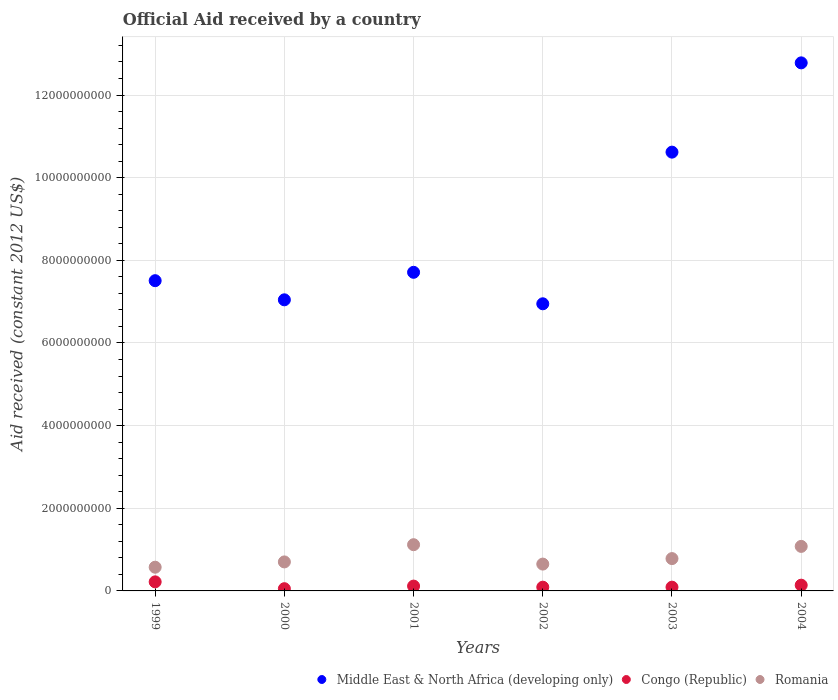Is the number of dotlines equal to the number of legend labels?
Offer a very short reply. Yes. What is the net official aid received in Middle East & North Africa (developing only) in 2003?
Keep it short and to the point. 1.06e+1. Across all years, what is the maximum net official aid received in Congo (Republic)?
Provide a succinct answer. 2.19e+08. Across all years, what is the minimum net official aid received in Romania?
Give a very brief answer. 5.74e+08. What is the total net official aid received in Congo (Republic) in the graph?
Provide a succinct answer. 7.10e+08. What is the difference between the net official aid received in Congo (Republic) in 2000 and that in 2003?
Offer a very short reply. -3.72e+07. What is the difference between the net official aid received in Congo (Republic) in 1999 and the net official aid received in Middle East & North Africa (developing only) in 2000?
Ensure brevity in your answer.  -6.83e+09. What is the average net official aid received in Congo (Republic) per year?
Give a very brief answer. 1.18e+08. In the year 2002, what is the difference between the net official aid received in Congo (Republic) and net official aid received in Romania?
Your answer should be compact. -5.59e+08. What is the ratio of the net official aid received in Romania in 2001 to that in 2004?
Offer a very short reply. 1.04. What is the difference between the highest and the second highest net official aid received in Romania?
Offer a very short reply. 4.10e+07. What is the difference between the highest and the lowest net official aid received in Congo (Republic)?
Ensure brevity in your answer.  1.65e+08. Is the sum of the net official aid received in Romania in 2000 and 2002 greater than the maximum net official aid received in Middle East & North Africa (developing only) across all years?
Give a very brief answer. No. Is the net official aid received in Romania strictly greater than the net official aid received in Congo (Republic) over the years?
Ensure brevity in your answer.  Yes. Is the net official aid received in Congo (Republic) strictly less than the net official aid received in Romania over the years?
Give a very brief answer. Yes. How many years are there in the graph?
Provide a short and direct response. 6. Does the graph contain any zero values?
Your answer should be compact. No. Where does the legend appear in the graph?
Keep it short and to the point. Bottom right. How many legend labels are there?
Provide a succinct answer. 3. What is the title of the graph?
Your answer should be compact. Official Aid received by a country. Does "Namibia" appear as one of the legend labels in the graph?
Provide a short and direct response. No. What is the label or title of the X-axis?
Offer a very short reply. Years. What is the label or title of the Y-axis?
Offer a very short reply. Aid received (constant 2012 US$). What is the Aid received (constant 2012 US$) of Middle East & North Africa (developing only) in 1999?
Your response must be concise. 7.51e+09. What is the Aid received (constant 2012 US$) in Congo (Republic) in 1999?
Your answer should be compact. 2.19e+08. What is the Aid received (constant 2012 US$) of Romania in 1999?
Provide a short and direct response. 5.74e+08. What is the Aid received (constant 2012 US$) of Middle East & North Africa (developing only) in 2000?
Ensure brevity in your answer.  7.04e+09. What is the Aid received (constant 2012 US$) in Congo (Republic) in 2000?
Your answer should be very brief. 5.38e+07. What is the Aid received (constant 2012 US$) of Romania in 2000?
Your answer should be very brief. 7.02e+08. What is the Aid received (constant 2012 US$) of Middle East & North Africa (developing only) in 2001?
Your answer should be very brief. 7.71e+09. What is the Aid received (constant 2012 US$) in Congo (Republic) in 2001?
Your response must be concise. 1.17e+08. What is the Aid received (constant 2012 US$) in Romania in 2001?
Provide a succinct answer. 1.12e+09. What is the Aid received (constant 2012 US$) of Middle East & North Africa (developing only) in 2002?
Your answer should be very brief. 6.95e+09. What is the Aid received (constant 2012 US$) of Congo (Republic) in 2002?
Your answer should be compact. 9.06e+07. What is the Aid received (constant 2012 US$) in Romania in 2002?
Make the answer very short. 6.49e+08. What is the Aid received (constant 2012 US$) in Middle East & North Africa (developing only) in 2003?
Give a very brief answer. 1.06e+1. What is the Aid received (constant 2012 US$) in Congo (Republic) in 2003?
Ensure brevity in your answer.  9.11e+07. What is the Aid received (constant 2012 US$) of Romania in 2003?
Your answer should be compact. 7.82e+08. What is the Aid received (constant 2012 US$) of Middle East & North Africa (developing only) in 2004?
Your answer should be very brief. 1.28e+1. What is the Aid received (constant 2012 US$) of Congo (Republic) in 2004?
Provide a succinct answer. 1.39e+08. What is the Aid received (constant 2012 US$) in Romania in 2004?
Offer a very short reply. 1.08e+09. Across all years, what is the maximum Aid received (constant 2012 US$) in Middle East & North Africa (developing only)?
Provide a short and direct response. 1.28e+1. Across all years, what is the maximum Aid received (constant 2012 US$) of Congo (Republic)?
Offer a very short reply. 2.19e+08. Across all years, what is the maximum Aid received (constant 2012 US$) of Romania?
Your answer should be very brief. 1.12e+09. Across all years, what is the minimum Aid received (constant 2012 US$) of Middle East & North Africa (developing only)?
Your answer should be very brief. 6.95e+09. Across all years, what is the minimum Aid received (constant 2012 US$) of Congo (Republic)?
Give a very brief answer. 5.38e+07. Across all years, what is the minimum Aid received (constant 2012 US$) in Romania?
Make the answer very short. 5.74e+08. What is the total Aid received (constant 2012 US$) in Middle East & North Africa (developing only) in the graph?
Your answer should be very brief. 5.26e+1. What is the total Aid received (constant 2012 US$) of Congo (Republic) in the graph?
Offer a terse response. 7.10e+08. What is the total Aid received (constant 2012 US$) of Romania in the graph?
Offer a very short reply. 4.90e+09. What is the difference between the Aid received (constant 2012 US$) of Middle East & North Africa (developing only) in 1999 and that in 2000?
Ensure brevity in your answer.  4.63e+08. What is the difference between the Aid received (constant 2012 US$) in Congo (Republic) in 1999 and that in 2000?
Your response must be concise. 1.65e+08. What is the difference between the Aid received (constant 2012 US$) in Romania in 1999 and that in 2000?
Ensure brevity in your answer.  -1.28e+08. What is the difference between the Aid received (constant 2012 US$) of Middle East & North Africa (developing only) in 1999 and that in 2001?
Provide a succinct answer. -2.03e+08. What is the difference between the Aid received (constant 2012 US$) of Congo (Republic) in 1999 and that in 2001?
Your answer should be very brief. 1.02e+08. What is the difference between the Aid received (constant 2012 US$) of Romania in 1999 and that in 2001?
Make the answer very short. -5.45e+08. What is the difference between the Aid received (constant 2012 US$) of Middle East & North Africa (developing only) in 1999 and that in 2002?
Ensure brevity in your answer.  5.59e+08. What is the difference between the Aid received (constant 2012 US$) of Congo (Republic) in 1999 and that in 2002?
Give a very brief answer. 1.29e+08. What is the difference between the Aid received (constant 2012 US$) of Romania in 1999 and that in 2002?
Provide a succinct answer. -7.56e+07. What is the difference between the Aid received (constant 2012 US$) of Middle East & North Africa (developing only) in 1999 and that in 2003?
Your response must be concise. -3.11e+09. What is the difference between the Aid received (constant 2012 US$) in Congo (Republic) in 1999 and that in 2003?
Your answer should be compact. 1.28e+08. What is the difference between the Aid received (constant 2012 US$) of Romania in 1999 and that in 2003?
Give a very brief answer. -2.09e+08. What is the difference between the Aid received (constant 2012 US$) in Middle East & North Africa (developing only) in 1999 and that in 2004?
Make the answer very short. -5.27e+09. What is the difference between the Aid received (constant 2012 US$) of Congo (Republic) in 1999 and that in 2004?
Offer a very short reply. 8.02e+07. What is the difference between the Aid received (constant 2012 US$) in Romania in 1999 and that in 2004?
Ensure brevity in your answer.  -5.04e+08. What is the difference between the Aid received (constant 2012 US$) in Middle East & North Africa (developing only) in 2000 and that in 2001?
Ensure brevity in your answer.  -6.66e+08. What is the difference between the Aid received (constant 2012 US$) of Congo (Republic) in 2000 and that in 2001?
Your answer should be compact. -6.31e+07. What is the difference between the Aid received (constant 2012 US$) of Romania in 2000 and that in 2001?
Your answer should be very brief. -4.17e+08. What is the difference between the Aid received (constant 2012 US$) of Middle East & North Africa (developing only) in 2000 and that in 2002?
Give a very brief answer. 9.62e+07. What is the difference between the Aid received (constant 2012 US$) in Congo (Republic) in 2000 and that in 2002?
Give a very brief answer. -3.68e+07. What is the difference between the Aid received (constant 2012 US$) of Romania in 2000 and that in 2002?
Your response must be concise. 5.26e+07. What is the difference between the Aid received (constant 2012 US$) of Middle East & North Africa (developing only) in 2000 and that in 2003?
Provide a succinct answer. -3.57e+09. What is the difference between the Aid received (constant 2012 US$) in Congo (Republic) in 2000 and that in 2003?
Keep it short and to the point. -3.72e+07. What is the difference between the Aid received (constant 2012 US$) of Romania in 2000 and that in 2003?
Provide a succinct answer. -8.04e+07. What is the difference between the Aid received (constant 2012 US$) of Middle East & North Africa (developing only) in 2000 and that in 2004?
Offer a terse response. -5.73e+09. What is the difference between the Aid received (constant 2012 US$) in Congo (Republic) in 2000 and that in 2004?
Your answer should be compact. -8.52e+07. What is the difference between the Aid received (constant 2012 US$) in Romania in 2000 and that in 2004?
Ensure brevity in your answer.  -3.76e+08. What is the difference between the Aid received (constant 2012 US$) of Middle East & North Africa (developing only) in 2001 and that in 2002?
Your answer should be compact. 7.62e+08. What is the difference between the Aid received (constant 2012 US$) of Congo (Republic) in 2001 and that in 2002?
Provide a short and direct response. 2.63e+07. What is the difference between the Aid received (constant 2012 US$) in Romania in 2001 and that in 2002?
Ensure brevity in your answer.  4.69e+08. What is the difference between the Aid received (constant 2012 US$) of Middle East & North Africa (developing only) in 2001 and that in 2003?
Your answer should be very brief. -2.91e+09. What is the difference between the Aid received (constant 2012 US$) of Congo (Republic) in 2001 and that in 2003?
Keep it short and to the point. 2.58e+07. What is the difference between the Aid received (constant 2012 US$) in Romania in 2001 and that in 2003?
Make the answer very short. 3.36e+08. What is the difference between the Aid received (constant 2012 US$) in Middle East & North Africa (developing only) in 2001 and that in 2004?
Your response must be concise. -5.07e+09. What is the difference between the Aid received (constant 2012 US$) of Congo (Republic) in 2001 and that in 2004?
Keep it short and to the point. -2.21e+07. What is the difference between the Aid received (constant 2012 US$) in Romania in 2001 and that in 2004?
Offer a very short reply. 4.10e+07. What is the difference between the Aid received (constant 2012 US$) in Middle East & North Africa (developing only) in 2002 and that in 2003?
Keep it short and to the point. -3.67e+09. What is the difference between the Aid received (constant 2012 US$) of Congo (Republic) in 2002 and that in 2003?
Your answer should be compact. -5.00e+05. What is the difference between the Aid received (constant 2012 US$) of Romania in 2002 and that in 2003?
Keep it short and to the point. -1.33e+08. What is the difference between the Aid received (constant 2012 US$) in Middle East & North Africa (developing only) in 2002 and that in 2004?
Give a very brief answer. -5.83e+09. What is the difference between the Aid received (constant 2012 US$) in Congo (Republic) in 2002 and that in 2004?
Give a very brief answer. -4.84e+07. What is the difference between the Aid received (constant 2012 US$) in Romania in 2002 and that in 2004?
Give a very brief answer. -4.28e+08. What is the difference between the Aid received (constant 2012 US$) of Middle East & North Africa (developing only) in 2003 and that in 2004?
Keep it short and to the point. -2.16e+09. What is the difference between the Aid received (constant 2012 US$) in Congo (Republic) in 2003 and that in 2004?
Give a very brief answer. -4.79e+07. What is the difference between the Aid received (constant 2012 US$) in Romania in 2003 and that in 2004?
Your response must be concise. -2.95e+08. What is the difference between the Aid received (constant 2012 US$) in Middle East & North Africa (developing only) in 1999 and the Aid received (constant 2012 US$) in Congo (Republic) in 2000?
Offer a very short reply. 7.45e+09. What is the difference between the Aid received (constant 2012 US$) of Middle East & North Africa (developing only) in 1999 and the Aid received (constant 2012 US$) of Romania in 2000?
Give a very brief answer. 6.81e+09. What is the difference between the Aid received (constant 2012 US$) in Congo (Republic) in 1999 and the Aid received (constant 2012 US$) in Romania in 2000?
Offer a very short reply. -4.83e+08. What is the difference between the Aid received (constant 2012 US$) in Middle East & North Africa (developing only) in 1999 and the Aid received (constant 2012 US$) in Congo (Republic) in 2001?
Keep it short and to the point. 7.39e+09. What is the difference between the Aid received (constant 2012 US$) in Middle East & North Africa (developing only) in 1999 and the Aid received (constant 2012 US$) in Romania in 2001?
Give a very brief answer. 6.39e+09. What is the difference between the Aid received (constant 2012 US$) of Congo (Republic) in 1999 and the Aid received (constant 2012 US$) of Romania in 2001?
Keep it short and to the point. -8.99e+08. What is the difference between the Aid received (constant 2012 US$) of Middle East & North Africa (developing only) in 1999 and the Aid received (constant 2012 US$) of Congo (Republic) in 2002?
Offer a very short reply. 7.42e+09. What is the difference between the Aid received (constant 2012 US$) in Middle East & North Africa (developing only) in 1999 and the Aid received (constant 2012 US$) in Romania in 2002?
Your response must be concise. 6.86e+09. What is the difference between the Aid received (constant 2012 US$) of Congo (Republic) in 1999 and the Aid received (constant 2012 US$) of Romania in 2002?
Your answer should be very brief. -4.30e+08. What is the difference between the Aid received (constant 2012 US$) of Middle East & North Africa (developing only) in 1999 and the Aid received (constant 2012 US$) of Congo (Republic) in 2003?
Give a very brief answer. 7.42e+09. What is the difference between the Aid received (constant 2012 US$) in Middle East & North Africa (developing only) in 1999 and the Aid received (constant 2012 US$) in Romania in 2003?
Provide a short and direct response. 6.72e+09. What is the difference between the Aid received (constant 2012 US$) of Congo (Republic) in 1999 and the Aid received (constant 2012 US$) of Romania in 2003?
Give a very brief answer. -5.63e+08. What is the difference between the Aid received (constant 2012 US$) of Middle East & North Africa (developing only) in 1999 and the Aid received (constant 2012 US$) of Congo (Republic) in 2004?
Your answer should be very brief. 7.37e+09. What is the difference between the Aid received (constant 2012 US$) in Middle East & North Africa (developing only) in 1999 and the Aid received (constant 2012 US$) in Romania in 2004?
Your response must be concise. 6.43e+09. What is the difference between the Aid received (constant 2012 US$) in Congo (Republic) in 1999 and the Aid received (constant 2012 US$) in Romania in 2004?
Offer a very short reply. -8.58e+08. What is the difference between the Aid received (constant 2012 US$) in Middle East & North Africa (developing only) in 2000 and the Aid received (constant 2012 US$) in Congo (Republic) in 2001?
Your response must be concise. 6.93e+09. What is the difference between the Aid received (constant 2012 US$) of Middle East & North Africa (developing only) in 2000 and the Aid received (constant 2012 US$) of Romania in 2001?
Offer a terse response. 5.93e+09. What is the difference between the Aid received (constant 2012 US$) of Congo (Republic) in 2000 and the Aid received (constant 2012 US$) of Romania in 2001?
Offer a terse response. -1.06e+09. What is the difference between the Aid received (constant 2012 US$) of Middle East & North Africa (developing only) in 2000 and the Aid received (constant 2012 US$) of Congo (Republic) in 2002?
Provide a succinct answer. 6.95e+09. What is the difference between the Aid received (constant 2012 US$) of Middle East & North Africa (developing only) in 2000 and the Aid received (constant 2012 US$) of Romania in 2002?
Provide a succinct answer. 6.40e+09. What is the difference between the Aid received (constant 2012 US$) of Congo (Republic) in 2000 and the Aid received (constant 2012 US$) of Romania in 2002?
Keep it short and to the point. -5.95e+08. What is the difference between the Aid received (constant 2012 US$) in Middle East & North Africa (developing only) in 2000 and the Aid received (constant 2012 US$) in Congo (Republic) in 2003?
Ensure brevity in your answer.  6.95e+09. What is the difference between the Aid received (constant 2012 US$) in Middle East & North Africa (developing only) in 2000 and the Aid received (constant 2012 US$) in Romania in 2003?
Ensure brevity in your answer.  6.26e+09. What is the difference between the Aid received (constant 2012 US$) of Congo (Republic) in 2000 and the Aid received (constant 2012 US$) of Romania in 2003?
Ensure brevity in your answer.  -7.28e+08. What is the difference between the Aid received (constant 2012 US$) of Middle East & North Africa (developing only) in 2000 and the Aid received (constant 2012 US$) of Congo (Republic) in 2004?
Your answer should be compact. 6.91e+09. What is the difference between the Aid received (constant 2012 US$) in Middle East & North Africa (developing only) in 2000 and the Aid received (constant 2012 US$) in Romania in 2004?
Provide a succinct answer. 5.97e+09. What is the difference between the Aid received (constant 2012 US$) of Congo (Republic) in 2000 and the Aid received (constant 2012 US$) of Romania in 2004?
Ensure brevity in your answer.  -1.02e+09. What is the difference between the Aid received (constant 2012 US$) of Middle East & North Africa (developing only) in 2001 and the Aid received (constant 2012 US$) of Congo (Republic) in 2002?
Make the answer very short. 7.62e+09. What is the difference between the Aid received (constant 2012 US$) of Middle East & North Africa (developing only) in 2001 and the Aid received (constant 2012 US$) of Romania in 2002?
Offer a terse response. 7.06e+09. What is the difference between the Aid received (constant 2012 US$) in Congo (Republic) in 2001 and the Aid received (constant 2012 US$) in Romania in 2002?
Provide a succinct answer. -5.32e+08. What is the difference between the Aid received (constant 2012 US$) in Middle East & North Africa (developing only) in 2001 and the Aid received (constant 2012 US$) in Congo (Republic) in 2003?
Offer a terse response. 7.62e+09. What is the difference between the Aid received (constant 2012 US$) of Middle East & North Africa (developing only) in 2001 and the Aid received (constant 2012 US$) of Romania in 2003?
Ensure brevity in your answer.  6.93e+09. What is the difference between the Aid received (constant 2012 US$) of Congo (Republic) in 2001 and the Aid received (constant 2012 US$) of Romania in 2003?
Offer a very short reply. -6.65e+08. What is the difference between the Aid received (constant 2012 US$) in Middle East & North Africa (developing only) in 2001 and the Aid received (constant 2012 US$) in Congo (Republic) in 2004?
Provide a short and direct response. 7.57e+09. What is the difference between the Aid received (constant 2012 US$) of Middle East & North Africa (developing only) in 2001 and the Aid received (constant 2012 US$) of Romania in 2004?
Make the answer very short. 6.63e+09. What is the difference between the Aid received (constant 2012 US$) of Congo (Republic) in 2001 and the Aid received (constant 2012 US$) of Romania in 2004?
Ensure brevity in your answer.  -9.61e+08. What is the difference between the Aid received (constant 2012 US$) in Middle East & North Africa (developing only) in 2002 and the Aid received (constant 2012 US$) in Congo (Republic) in 2003?
Offer a very short reply. 6.86e+09. What is the difference between the Aid received (constant 2012 US$) of Middle East & North Africa (developing only) in 2002 and the Aid received (constant 2012 US$) of Romania in 2003?
Keep it short and to the point. 6.17e+09. What is the difference between the Aid received (constant 2012 US$) in Congo (Republic) in 2002 and the Aid received (constant 2012 US$) in Romania in 2003?
Make the answer very short. -6.92e+08. What is the difference between the Aid received (constant 2012 US$) of Middle East & North Africa (developing only) in 2002 and the Aid received (constant 2012 US$) of Congo (Republic) in 2004?
Offer a very short reply. 6.81e+09. What is the difference between the Aid received (constant 2012 US$) in Middle East & North Africa (developing only) in 2002 and the Aid received (constant 2012 US$) in Romania in 2004?
Make the answer very short. 5.87e+09. What is the difference between the Aid received (constant 2012 US$) of Congo (Republic) in 2002 and the Aid received (constant 2012 US$) of Romania in 2004?
Offer a terse response. -9.87e+08. What is the difference between the Aid received (constant 2012 US$) in Middle East & North Africa (developing only) in 2003 and the Aid received (constant 2012 US$) in Congo (Republic) in 2004?
Offer a terse response. 1.05e+1. What is the difference between the Aid received (constant 2012 US$) in Middle East & North Africa (developing only) in 2003 and the Aid received (constant 2012 US$) in Romania in 2004?
Provide a short and direct response. 9.54e+09. What is the difference between the Aid received (constant 2012 US$) in Congo (Republic) in 2003 and the Aid received (constant 2012 US$) in Romania in 2004?
Keep it short and to the point. -9.86e+08. What is the average Aid received (constant 2012 US$) in Middle East & North Africa (developing only) per year?
Your answer should be compact. 8.77e+09. What is the average Aid received (constant 2012 US$) in Congo (Republic) per year?
Your answer should be very brief. 1.18e+08. What is the average Aid received (constant 2012 US$) in Romania per year?
Offer a terse response. 8.17e+08. In the year 1999, what is the difference between the Aid received (constant 2012 US$) of Middle East & North Africa (developing only) and Aid received (constant 2012 US$) of Congo (Republic)?
Provide a short and direct response. 7.29e+09. In the year 1999, what is the difference between the Aid received (constant 2012 US$) in Middle East & North Africa (developing only) and Aid received (constant 2012 US$) in Romania?
Your answer should be very brief. 6.93e+09. In the year 1999, what is the difference between the Aid received (constant 2012 US$) in Congo (Republic) and Aid received (constant 2012 US$) in Romania?
Provide a succinct answer. -3.54e+08. In the year 2000, what is the difference between the Aid received (constant 2012 US$) of Middle East & North Africa (developing only) and Aid received (constant 2012 US$) of Congo (Republic)?
Offer a terse response. 6.99e+09. In the year 2000, what is the difference between the Aid received (constant 2012 US$) of Middle East & North Africa (developing only) and Aid received (constant 2012 US$) of Romania?
Keep it short and to the point. 6.34e+09. In the year 2000, what is the difference between the Aid received (constant 2012 US$) in Congo (Republic) and Aid received (constant 2012 US$) in Romania?
Your answer should be very brief. -6.48e+08. In the year 2001, what is the difference between the Aid received (constant 2012 US$) in Middle East & North Africa (developing only) and Aid received (constant 2012 US$) in Congo (Republic)?
Provide a succinct answer. 7.59e+09. In the year 2001, what is the difference between the Aid received (constant 2012 US$) in Middle East & North Africa (developing only) and Aid received (constant 2012 US$) in Romania?
Provide a succinct answer. 6.59e+09. In the year 2001, what is the difference between the Aid received (constant 2012 US$) of Congo (Republic) and Aid received (constant 2012 US$) of Romania?
Your answer should be very brief. -1.00e+09. In the year 2002, what is the difference between the Aid received (constant 2012 US$) in Middle East & North Africa (developing only) and Aid received (constant 2012 US$) in Congo (Republic)?
Your answer should be compact. 6.86e+09. In the year 2002, what is the difference between the Aid received (constant 2012 US$) of Middle East & North Africa (developing only) and Aid received (constant 2012 US$) of Romania?
Offer a terse response. 6.30e+09. In the year 2002, what is the difference between the Aid received (constant 2012 US$) of Congo (Republic) and Aid received (constant 2012 US$) of Romania?
Your answer should be very brief. -5.59e+08. In the year 2003, what is the difference between the Aid received (constant 2012 US$) in Middle East & North Africa (developing only) and Aid received (constant 2012 US$) in Congo (Republic)?
Offer a very short reply. 1.05e+1. In the year 2003, what is the difference between the Aid received (constant 2012 US$) of Middle East & North Africa (developing only) and Aid received (constant 2012 US$) of Romania?
Provide a succinct answer. 9.84e+09. In the year 2003, what is the difference between the Aid received (constant 2012 US$) in Congo (Republic) and Aid received (constant 2012 US$) in Romania?
Provide a short and direct response. -6.91e+08. In the year 2004, what is the difference between the Aid received (constant 2012 US$) in Middle East & North Africa (developing only) and Aid received (constant 2012 US$) in Congo (Republic)?
Offer a terse response. 1.26e+1. In the year 2004, what is the difference between the Aid received (constant 2012 US$) in Middle East & North Africa (developing only) and Aid received (constant 2012 US$) in Romania?
Offer a very short reply. 1.17e+1. In the year 2004, what is the difference between the Aid received (constant 2012 US$) in Congo (Republic) and Aid received (constant 2012 US$) in Romania?
Your response must be concise. -9.38e+08. What is the ratio of the Aid received (constant 2012 US$) in Middle East & North Africa (developing only) in 1999 to that in 2000?
Provide a succinct answer. 1.07. What is the ratio of the Aid received (constant 2012 US$) in Congo (Republic) in 1999 to that in 2000?
Give a very brief answer. 4.07. What is the ratio of the Aid received (constant 2012 US$) of Romania in 1999 to that in 2000?
Offer a very short reply. 0.82. What is the ratio of the Aid received (constant 2012 US$) in Middle East & North Africa (developing only) in 1999 to that in 2001?
Offer a terse response. 0.97. What is the ratio of the Aid received (constant 2012 US$) of Congo (Republic) in 1999 to that in 2001?
Offer a very short reply. 1.88. What is the ratio of the Aid received (constant 2012 US$) of Romania in 1999 to that in 2001?
Your answer should be very brief. 0.51. What is the ratio of the Aid received (constant 2012 US$) of Middle East & North Africa (developing only) in 1999 to that in 2002?
Provide a short and direct response. 1.08. What is the ratio of the Aid received (constant 2012 US$) in Congo (Republic) in 1999 to that in 2002?
Ensure brevity in your answer.  2.42. What is the ratio of the Aid received (constant 2012 US$) of Romania in 1999 to that in 2002?
Your answer should be compact. 0.88. What is the ratio of the Aid received (constant 2012 US$) in Middle East & North Africa (developing only) in 1999 to that in 2003?
Keep it short and to the point. 0.71. What is the ratio of the Aid received (constant 2012 US$) of Congo (Republic) in 1999 to that in 2003?
Make the answer very short. 2.41. What is the ratio of the Aid received (constant 2012 US$) in Romania in 1999 to that in 2003?
Provide a succinct answer. 0.73. What is the ratio of the Aid received (constant 2012 US$) of Middle East & North Africa (developing only) in 1999 to that in 2004?
Offer a very short reply. 0.59. What is the ratio of the Aid received (constant 2012 US$) of Congo (Republic) in 1999 to that in 2004?
Your answer should be very brief. 1.58. What is the ratio of the Aid received (constant 2012 US$) of Romania in 1999 to that in 2004?
Keep it short and to the point. 0.53. What is the ratio of the Aid received (constant 2012 US$) of Middle East & North Africa (developing only) in 2000 to that in 2001?
Offer a very short reply. 0.91. What is the ratio of the Aid received (constant 2012 US$) in Congo (Republic) in 2000 to that in 2001?
Your answer should be compact. 0.46. What is the ratio of the Aid received (constant 2012 US$) of Romania in 2000 to that in 2001?
Your response must be concise. 0.63. What is the ratio of the Aid received (constant 2012 US$) in Middle East & North Africa (developing only) in 2000 to that in 2002?
Make the answer very short. 1.01. What is the ratio of the Aid received (constant 2012 US$) of Congo (Republic) in 2000 to that in 2002?
Your answer should be very brief. 0.59. What is the ratio of the Aid received (constant 2012 US$) in Romania in 2000 to that in 2002?
Your answer should be very brief. 1.08. What is the ratio of the Aid received (constant 2012 US$) in Middle East & North Africa (developing only) in 2000 to that in 2003?
Offer a terse response. 0.66. What is the ratio of the Aid received (constant 2012 US$) of Congo (Republic) in 2000 to that in 2003?
Ensure brevity in your answer.  0.59. What is the ratio of the Aid received (constant 2012 US$) of Romania in 2000 to that in 2003?
Keep it short and to the point. 0.9. What is the ratio of the Aid received (constant 2012 US$) of Middle East & North Africa (developing only) in 2000 to that in 2004?
Your answer should be very brief. 0.55. What is the ratio of the Aid received (constant 2012 US$) in Congo (Republic) in 2000 to that in 2004?
Offer a terse response. 0.39. What is the ratio of the Aid received (constant 2012 US$) of Romania in 2000 to that in 2004?
Give a very brief answer. 0.65. What is the ratio of the Aid received (constant 2012 US$) in Middle East & North Africa (developing only) in 2001 to that in 2002?
Offer a terse response. 1.11. What is the ratio of the Aid received (constant 2012 US$) in Congo (Republic) in 2001 to that in 2002?
Your answer should be compact. 1.29. What is the ratio of the Aid received (constant 2012 US$) of Romania in 2001 to that in 2002?
Your answer should be very brief. 1.72. What is the ratio of the Aid received (constant 2012 US$) in Middle East & North Africa (developing only) in 2001 to that in 2003?
Keep it short and to the point. 0.73. What is the ratio of the Aid received (constant 2012 US$) of Congo (Republic) in 2001 to that in 2003?
Ensure brevity in your answer.  1.28. What is the ratio of the Aid received (constant 2012 US$) in Romania in 2001 to that in 2003?
Your response must be concise. 1.43. What is the ratio of the Aid received (constant 2012 US$) in Middle East & North Africa (developing only) in 2001 to that in 2004?
Your response must be concise. 0.6. What is the ratio of the Aid received (constant 2012 US$) of Congo (Republic) in 2001 to that in 2004?
Make the answer very short. 0.84. What is the ratio of the Aid received (constant 2012 US$) in Romania in 2001 to that in 2004?
Your answer should be compact. 1.04. What is the ratio of the Aid received (constant 2012 US$) of Middle East & North Africa (developing only) in 2002 to that in 2003?
Your answer should be very brief. 0.65. What is the ratio of the Aid received (constant 2012 US$) in Romania in 2002 to that in 2003?
Your answer should be compact. 0.83. What is the ratio of the Aid received (constant 2012 US$) in Middle East & North Africa (developing only) in 2002 to that in 2004?
Provide a succinct answer. 0.54. What is the ratio of the Aid received (constant 2012 US$) of Congo (Republic) in 2002 to that in 2004?
Your answer should be compact. 0.65. What is the ratio of the Aid received (constant 2012 US$) of Romania in 2002 to that in 2004?
Provide a succinct answer. 0.6. What is the ratio of the Aid received (constant 2012 US$) of Middle East & North Africa (developing only) in 2003 to that in 2004?
Ensure brevity in your answer.  0.83. What is the ratio of the Aid received (constant 2012 US$) of Congo (Republic) in 2003 to that in 2004?
Your answer should be compact. 0.66. What is the ratio of the Aid received (constant 2012 US$) of Romania in 2003 to that in 2004?
Provide a succinct answer. 0.73. What is the difference between the highest and the second highest Aid received (constant 2012 US$) in Middle East & North Africa (developing only)?
Provide a succinct answer. 2.16e+09. What is the difference between the highest and the second highest Aid received (constant 2012 US$) in Congo (Republic)?
Ensure brevity in your answer.  8.02e+07. What is the difference between the highest and the second highest Aid received (constant 2012 US$) in Romania?
Your response must be concise. 4.10e+07. What is the difference between the highest and the lowest Aid received (constant 2012 US$) in Middle East & North Africa (developing only)?
Keep it short and to the point. 5.83e+09. What is the difference between the highest and the lowest Aid received (constant 2012 US$) in Congo (Republic)?
Offer a terse response. 1.65e+08. What is the difference between the highest and the lowest Aid received (constant 2012 US$) of Romania?
Your answer should be compact. 5.45e+08. 